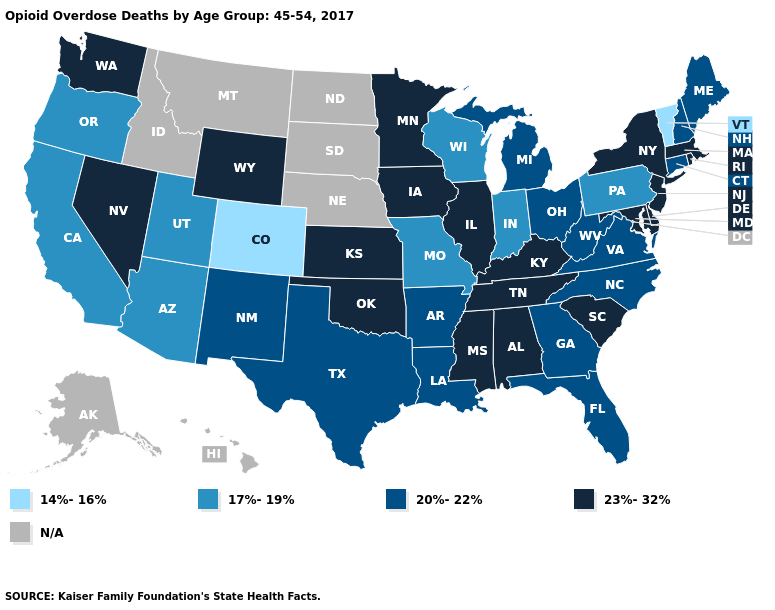Does California have the lowest value in the USA?
Quick response, please. No. Among the states that border California , does Nevada have the highest value?
Concise answer only. Yes. Which states have the highest value in the USA?
Short answer required. Alabama, Delaware, Illinois, Iowa, Kansas, Kentucky, Maryland, Massachusetts, Minnesota, Mississippi, Nevada, New Jersey, New York, Oklahoma, Rhode Island, South Carolina, Tennessee, Washington, Wyoming. What is the value of Illinois?
Be succinct. 23%-32%. What is the highest value in the South ?
Write a very short answer. 23%-32%. What is the lowest value in the USA?
Be succinct. 14%-16%. What is the highest value in the Northeast ?
Concise answer only. 23%-32%. Does New Hampshire have the lowest value in the USA?
Keep it brief. No. Name the states that have a value in the range N/A?
Write a very short answer. Alaska, Hawaii, Idaho, Montana, Nebraska, North Dakota, South Dakota. What is the value of Tennessee?
Give a very brief answer. 23%-32%. What is the lowest value in the MidWest?
Keep it brief. 17%-19%. Name the states that have a value in the range 23%-32%?
Be succinct. Alabama, Delaware, Illinois, Iowa, Kansas, Kentucky, Maryland, Massachusetts, Minnesota, Mississippi, Nevada, New Jersey, New York, Oklahoma, Rhode Island, South Carolina, Tennessee, Washington, Wyoming. What is the lowest value in the Northeast?
Concise answer only. 14%-16%. Name the states that have a value in the range 17%-19%?
Write a very short answer. Arizona, California, Indiana, Missouri, Oregon, Pennsylvania, Utah, Wisconsin. 